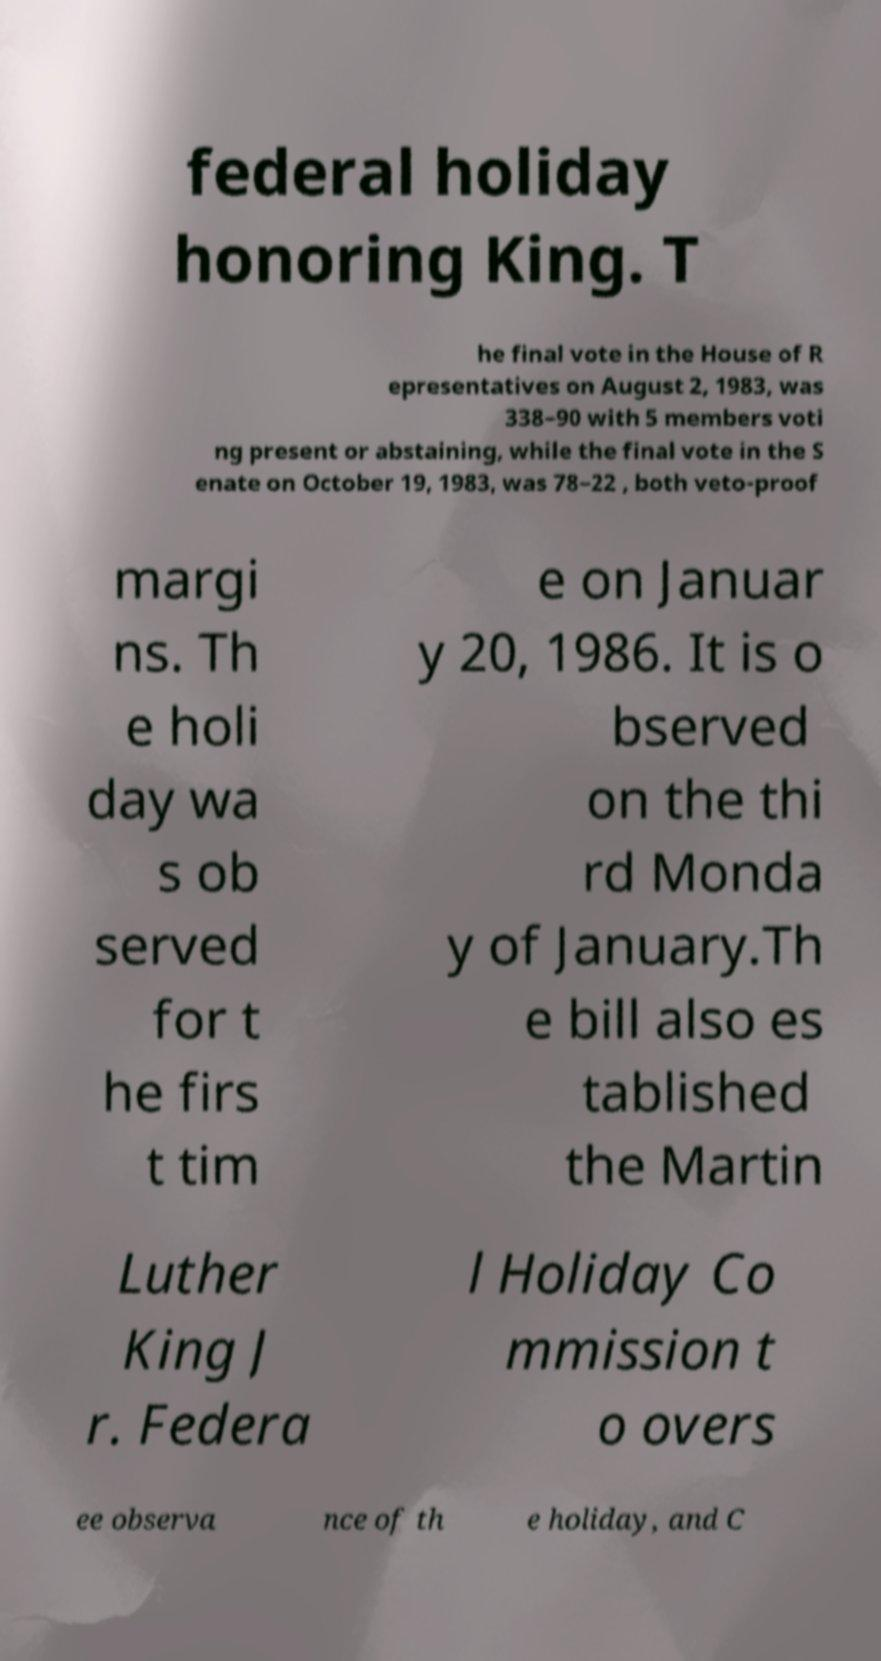For documentation purposes, I need the text within this image transcribed. Could you provide that? federal holiday honoring King. T he final vote in the House of R epresentatives on August 2, 1983, was 338–90 with 5 members voti ng present or abstaining, while the final vote in the S enate on October 19, 1983, was 78–22 , both veto-proof margi ns. Th e holi day wa s ob served for t he firs t tim e on Januar y 20, 1986. It is o bserved on the thi rd Monda y of January.Th e bill also es tablished the Martin Luther King J r. Federa l Holiday Co mmission t o overs ee observa nce of th e holiday, and C 